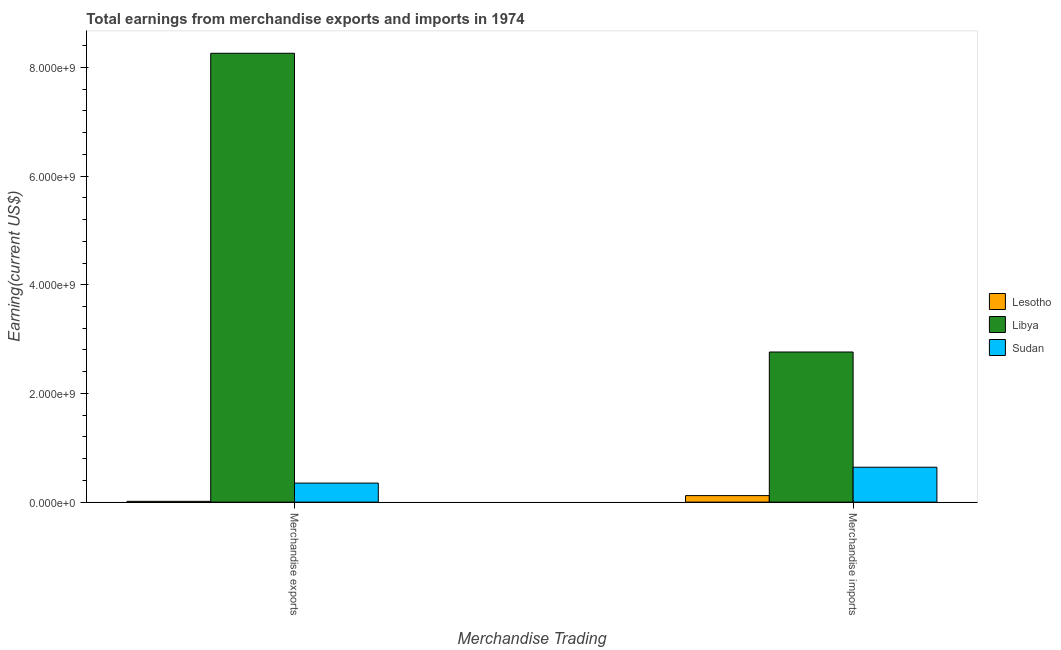How many different coloured bars are there?
Make the answer very short. 3. How many groups of bars are there?
Ensure brevity in your answer.  2. How many bars are there on the 1st tick from the left?
Your answer should be very brief. 3. How many bars are there on the 2nd tick from the right?
Provide a succinct answer. 3. What is the earnings from merchandise exports in Lesotho?
Offer a very short reply. 1.44e+07. Across all countries, what is the maximum earnings from merchandise imports?
Provide a short and direct response. 2.76e+09. Across all countries, what is the minimum earnings from merchandise exports?
Offer a terse response. 1.44e+07. In which country was the earnings from merchandise imports maximum?
Offer a terse response. Libya. In which country was the earnings from merchandise imports minimum?
Make the answer very short. Lesotho. What is the total earnings from merchandise imports in the graph?
Your response must be concise. 3.52e+09. What is the difference between the earnings from merchandise exports in Lesotho and that in Sudan?
Provide a succinct answer. -3.36e+08. What is the difference between the earnings from merchandise exports in Libya and the earnings from merchandise imports in Sudan?
Make the answer very short. 7.62e+09. What is the average earnings from merchandise exports per country?
Keep it short and to the point. 2.87e+09. What is the difference between the earnings from merchandise exports and earnings from merchandise imports in Lesotho?
Your response must be concise. -1.06e+08. What is the ratio of the earnings from merchandise imports in Lesotho to that in Sudan?
Offer a very short reply. 0.19. Is the earnings from merchandise imports in Libya less than that in Sudan?
Provide a succinct answer. No. In how many countries, is the earnings from merchandise imports greater than the average earnings from merchandise imports taken over all countries?
Make the answer very short. 1. What does the 3rd bar from the left in Merchandise imports represents?
Offer a very short reply. Sudan. What does the 2nd bar from the right in Merchandise imports represents?
Give a very brief answer. Libya. How many bars are there?
Keep it short and to the point. 6. Are all the bars in the graph horizontal?
Provide a short and direct response. No. How many countries are there in the graph?
Offer a very short reply. 3. What is the difference between two consecutive major ticks on the Y-axis?
Offer a very short reply. 2.00e+09. Are the values on the major ticks of Y-axis written in scientific E-notation?
Provide a short and direct response. Yes. Does the graph contain grids?
Your response must be concise. No. How many legend labels are there?
Offer a terse response. 3. What is the title of the graph?
Provide a short and direct response. Total earnings from merchandise exports and imports in 1974. Does "Lao PDR" appear as one of the legend labels in the graph?
Your response must be concise. No. What is the label or title of the X-axis?
Provide a succinct answer. Merchandise Trading. What is the label or title of the Y-axis?
Provide a succinct answer. Earning(current US$). What is the Earning(current US$) in Lesotho in Merchandise exports?
Provide a succinct answer. 1.44e+07. What is the Earning(current US$) in Libya in Merchandise exports?
Offer a very short reply. 8.26e+09. What is the Earning(current US$) of Sudan in Merchandise exports?
Your answer should be compact. 3.50e+08. What is the Earning(current US$) in Lesotho in Merchandise imports?
Your response must be concise. 1.20e+08. What is the Earning(current US$) of Libya in Merchandise imports?
Your response must be concise. 2.76e+09. What is the Earning(current US$) in Sudan in Merchandise imports?
Your response must be concise. 6.42e+08. Across all Merchandise Trading, what is the maximum Earning(current US$) of Lesotho?
Provide a succinct answer. 1.20e+08. Across all Merchandise Trading, what is the maximum Earning(current US$) of Libya?
Your response must be concise. 8.26e+09. Across all Merchandise Trading, what is the maximum Earning(current US$) of Sudan?
Keep it short and to the point. 6.42e+08. Across all Merchandise Trading, what is the minimum Earning(current US$) of Lesotho?
Provide a succinct answer. 1.44e+07. Across all Merchandise Trading, what is the minimum Earning(current US$) in Libya?
Keep it short and to the point. 2.76e+09. Across all Merchandise Trading, what is the minimum Earning(current US$) in Sudan?
Your answer should be compact. 3.50e+08. What is the total Earning(current US$) of Lesotho in the graph?
Your answer should be very brief. 1.35e+08. What is the total Earning(current US$) of Libya in the graph?
Your response must be concise. 1.10e+1. What is the total Earning(current US$) in Sudan in the graph?
Provide a short and direct response. 9.93e+08. What is the difference between the Earning(current US$) of Lesotho in Merchandise exports and that in Merchandise imports?
Give a very brief answer. -1.06e+08. What is the difference between the Earning(current US$) in Libya in Merchandise exports and that in Merchandise imports?
Give a very brief answer. 5.50e+09. What is the difference between the Earning(current US$) of Sudan in Merchandise exports and that in Merchandise imports?
Give a very brief answer. -2.92e+08. What is the difference between the Earning(current US$) in Lesotho in Merchandise exports and the Earning(current US$) in Libya in Merchandise imports?
Keep it short and to the point. -2.75e+09. What is the difference between the Earning(current US$) in Lesotho in Merchandise exports and the Earning(current US$) in Sudan in Merchandise imports?
Provide a succinct answer. -6.28e+08. What is the difference between the Earning(current US$) in Libya in Merchandise exports and the Earning(current US$) in Sudan in Merchandise imports?
Make the answer very short. 7.62e+09. What is the average Earning(current US$) in Lesotho per Merchandise Trading?
Your answer should be compact. 6.73e+07. What is the average Earning(current US$) in Libya per Merchandise Trading?
Make the answer very short. 5.51e+09. What is the average Earning(current US$) of Sudan per Merchandise Trading?
Provide a succinct answer. 4.96e+08. What is the difference between the Earning(current US$) in Lesotho and Earning(current US$) in Libya in Merchandise exports?
Keep it short and to the point. -8.24e+09. What is the difference between the Earning(current US$) of Lesotho and Earning(current US$) of Sudan in Merchandise exports?
Ensure brevity in your answer.  -3.36e+08. What is the difference between the Earning(current US$) of Libya and Earning(current US$) of Sudan in Merchandise exports?
Offer a terse response. 7.91e+09. What is the difference between the Earning(current US$) in Lesotho and Earning(current US$) in Libya in Merchandise imports?
Offer a very short reply. -2.64e+09. What is the difference between the Earning(current US$) of Lesotho and Earning(current US$) of Sudan in Merchandise imports?
Provide a short and direct response. -5.22e+08. What is the difference between the Earning(current US$) of Libya and Earning(current US$) of Sudan in Merchandise imports?
Keep it short and to the point. 2.12e+09. What is the ratio of the Earning(current US$) of Lesotho in Merchandise exports to that in Merchandise imports?
Your response must be concise. 0.12. What is the ratio of the Earning(current US$) in Libya in Merchandise exports to that in Merchandise imports?
Give a very brief answer. 2.99. What is the ratio of the Earning(current US$) in Sudan in Merchandise exports to that in Merchandise imports?
Your answer should be very brief. 0.55. What is the difference between the highest and the second highest Earning(current US$) in Lesotho?
Make the answer very short. 1.06e+08. What is the difference between the highest and the second highest Earning(current US$) of Libya?
Make the answer very short. 5.50e+09. What is the difference between the highest and the second highest Earning(current US$) of Sudan?
Provide a succinct answer. 2.92e+08. What is the difference between the highest and the lowest Earning(current US$) of Lesotho?
Your answer should be compact. 1.06e+08. What is the difference between the highest and the lowest Earning(current US$) of Libya?
Provide a short and direct response. 5.50e+09. What is the difference between the highest and the lowest Earning(current US$) of Sudan?
Keep it short and to the point. 2.92e+08. 